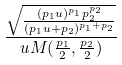<formula> <loc_0><loc_0><loc_500><loc_500>\frac { \sqrt { \frac { ( p _ { 1 } u ) ^ { p _ { 1 } } p _ { 2 } ^ { p _ { 2 } } } { ( p _ { 1 } u + p _ { 2 } ) ^ { p _ { 1 } + p _ { 2 } } } } } { u M ( \frac { p _ { 1 } } { 2 } , \frac { p _ { 2 } } { 2 } ) }</formula> 